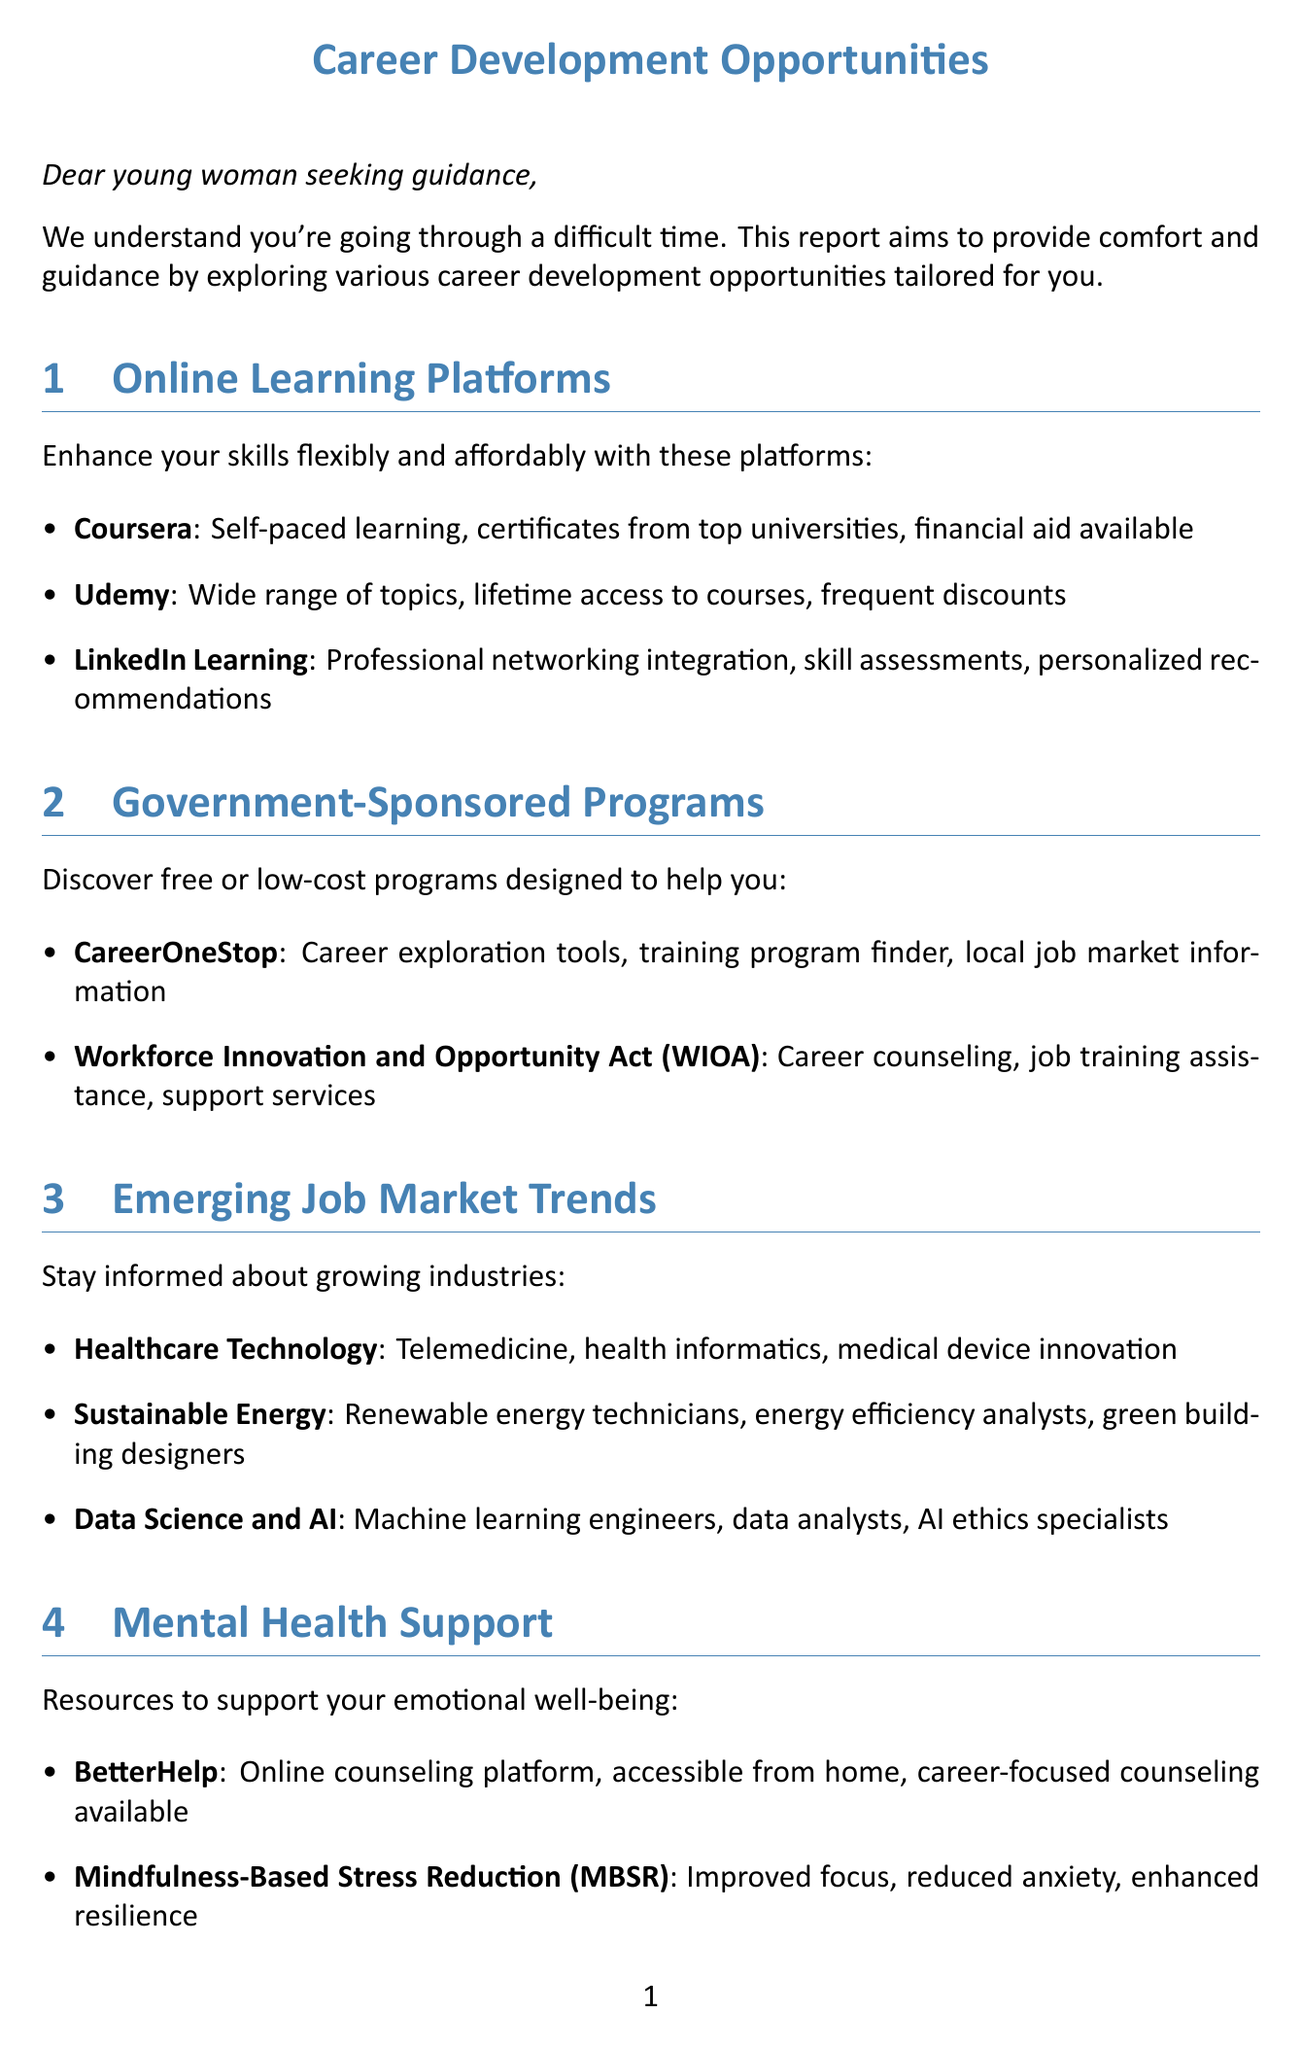what is the title of the first section? The first section discusses online learning platforms, which is indicated by its title.
Answer: Online Learning Platforms name one online learning platform mentioned in the document The document lists several online learning platforms for skill enhancement.
Answer: Coursera what are two services provided by CareerOneStop? The document outlines services provided by CareerOneStop, including various career-related tools.
Answer: Career exploration tools, training program finder which industry is mentioned as part of emerging job market trends? The document highlights multiple industries benefiting from job market trends.
Answer: Healthcare Technology how many examples of networking opportunities are provided? The document lists networking options, showing more than one example available for professionals.
Answer: Two what type of resources does BetterHelp provide? The document describes various mental health resources and their benefits.
Answer: Online counseling platform what type of financial assistance does SoFi offer? The document details financial resources for career transitions, including offerings from various organizations.
Answer: Personal loans for education what is a notable benefit of Udemy? The document highlights the features of various online learning platforms, including benefits of Udemy.
Answer: Lifetime access to courses which program offers career counseling and job training assistance? One of the government-sponsored programs provides specific services to help job seekers.
Answer: Workforce Innovation and Opportunity Act (WIOA) 